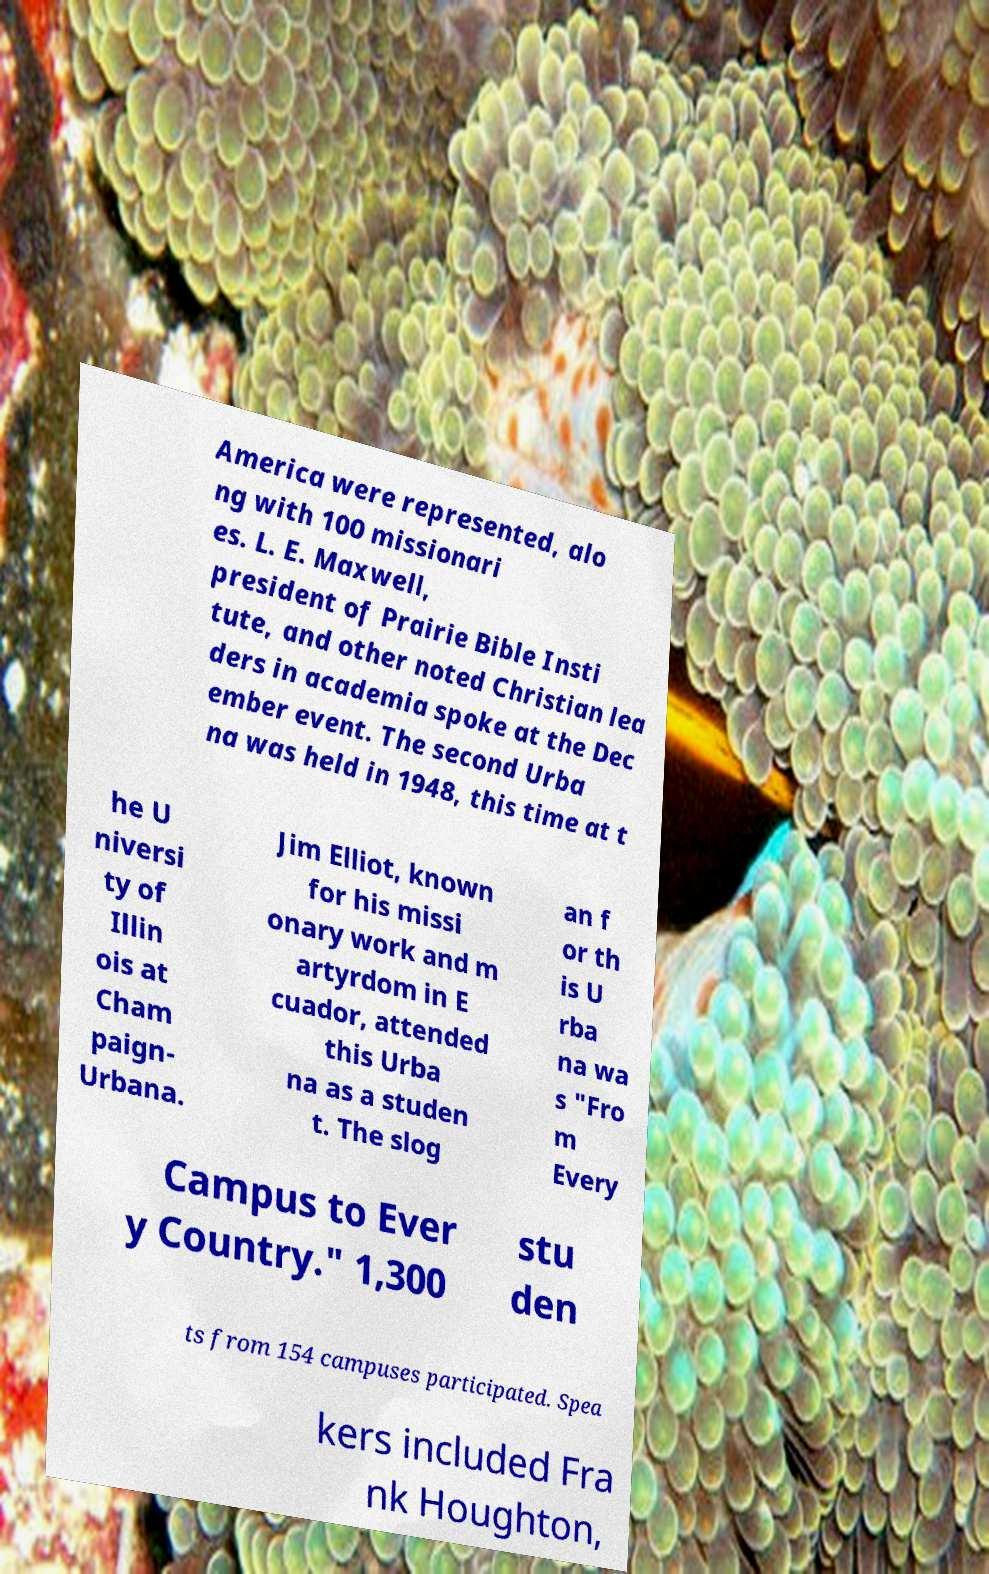Could you assist in decoding the text presented in this image and type it out clearly? America were represented, alo ng with 100 missionari es. L. E. Maxwell, president of Prairie Bible Insti tute, and other noted Christian lea ders in academia spoke at the Dec ember event. The second Urba na was held in 1948, this time at t he U niversi ty of Illin ois at Cham paign- Urbana. Jim Elliot, known for his missi onary work and m artyrdom in E cuador, attended this Urba na as a studen t. The slog an f or th is U rba na wa s "Fro m Every Campus to Ever y Country." 1,300 stu den ts from 154 campuses participated. Spea kers included Fra nk Houghton, 